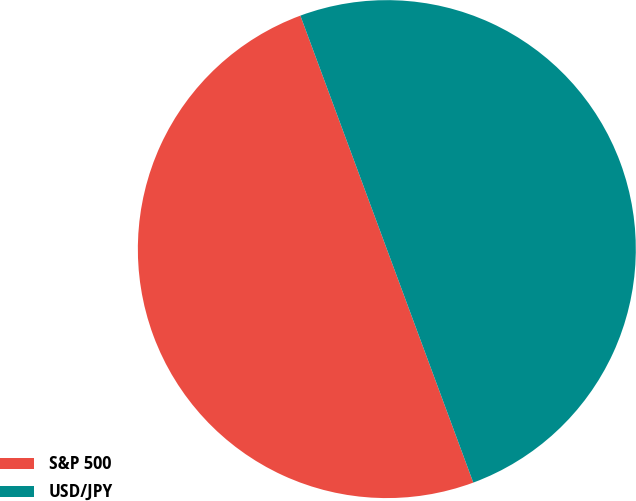Convert chart. <chart><loc_0><loc_0><loc_500><loc_500><pie_chart><fcel>S&P 500<fcel>USD/JPY<nl><fcel>50.0%<fcel>50.0%<nl></chart> 